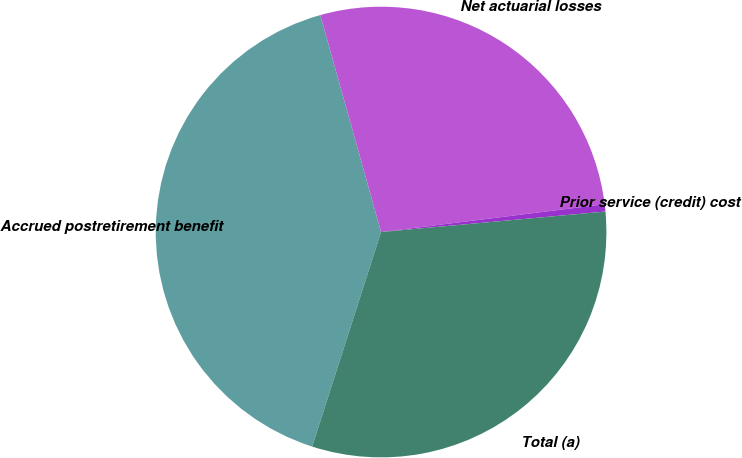<chart> <loc_0><loc_0><loc_500><loc_500><pie_chart><fcel>Accrued postretirement benefit<fcel>Net actuarial losses<fcel>Prior service (credit) cost<fcel>Total (a)<nl><fcel>40.71%<fcel>27.38%<fcel>0.52%<fcel>31.4%<nl></chart> 